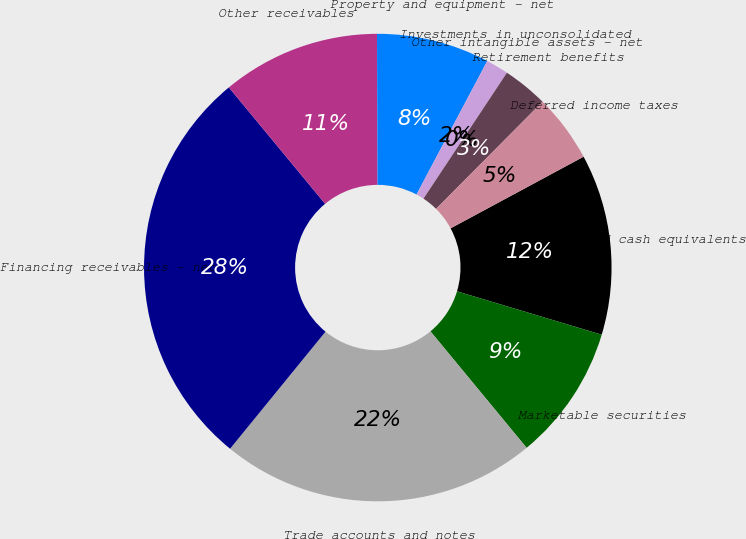<chart> <loc_0><loc_0><loc_500><loc_500><pie_chart><fcel>Cash and cash equivalents<fcel>Marketable securities<fcel>Trade accounts and notes<fcel>Financing receivables - net<fcel>Other receivables<fcel>Property and equipment - net<fcel>Investments in unconsolidated<fcel>Other intangible assets - net<fcel>Retirement benefits<fcel>Deferred income taxes<nl><fcel>12.5%<fcel>9.38%<fcel>21.87%<fcel>28.12%<fcel>10.94%<fcel>7.81%<fcel>1.56%<fcel>0.0%<fcel>3.13%<fcel>4.69%<nl></chart> 